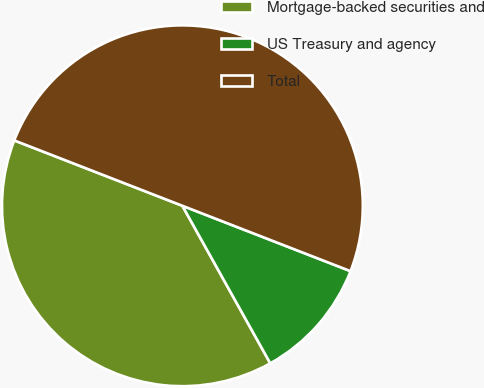<chart> <loc_0><loc_0><loc_500><loc_500><pie_chart><fcel>Mortgage-backed securities and<fcel>US Treasury and agency<fcel>Total<nl><fcel>39.0%<fcel>11.0%<fcel>50.0%<nl></chart> 